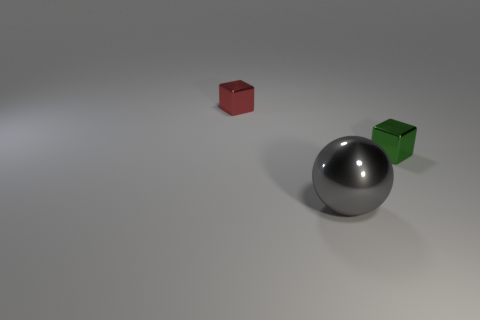How many things are either gray metal spheres or small red metallic cubes?
Ensure brevity in your answer.  2. There is a object that is on the right side of the gray thing; is its shape the same as the red shiny thing?
Provide a short and direct response. Yes. The tiny cube that is to the left of the metallic object that is right of the gray object is what color?
Make the answer very short. Red. Is the number of gray metal things less than the number of tiny metal cubes?
Make the answer very short. Yes. Are there any cyan cylinders made of the same material as the red object?
Offer a very short reply. No. Does the tiny red thing have the same shape as the metal object that is on the right side of the big gray metallic ball?
Offer a terse response. Yes. Are there any blocks to the right of the small green metallic thing?
Keep it short and to the point. No. What number of other large gray shiny objects are the same shape as the big metal object?
Your response must be concise. 0. Does the large gray thing have the same material as the tiny cube right of the small red shiny block?
Your response must be concise. Yes. How many big gray things are there?
Offer a very short reply. 1. 